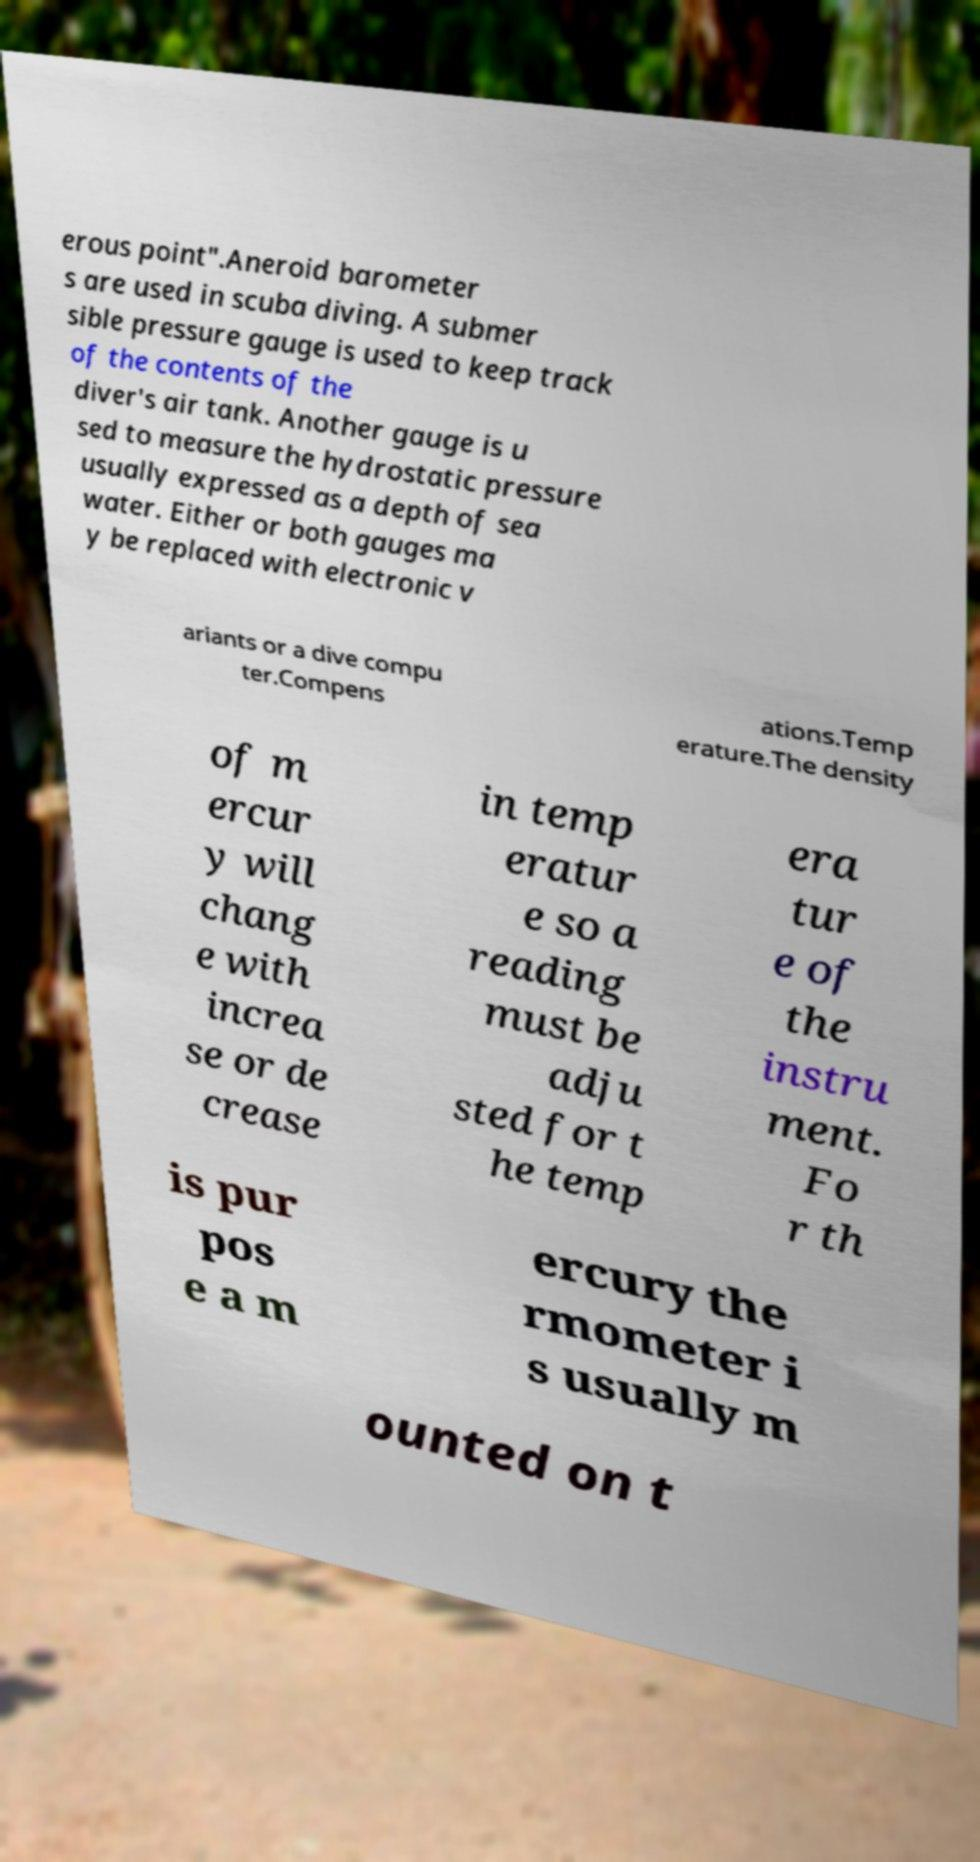Can you accurately transcribe the text from the provided image for me? erous point".Aneroid barometer s are used in scuba diving. A submer sible pressure gauge is used to keep track of the contents of the diver's air tank. Another gauge is u sed to measure the hydrostatic pressure usually expressed as a depth of sea water. Either or both gauges ma y be replaced with electronic v ariants or a dive compu ter.Compens ations.Temp erature.The density of m ercur y will chang e with increa se or de crease in temp eratur e so a reading must be adju sted for t he temp era tur e of the instru ment. Fo r th is pur pos e a m ercury the rmometer i s usually m ounted on t 